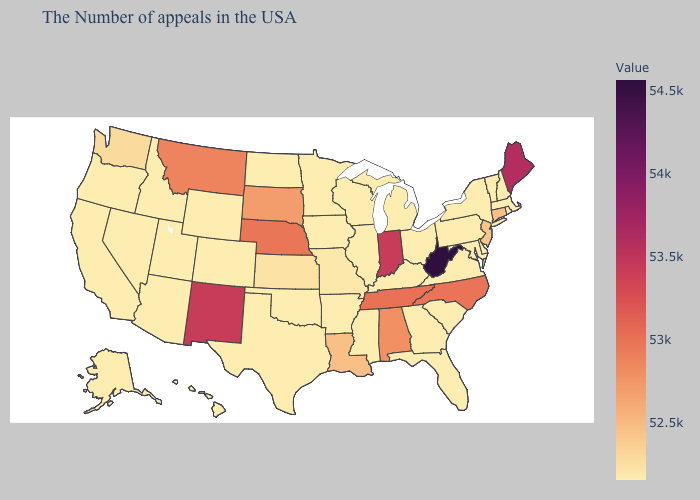Does the map have missing data?
Write a very short answer. No. Does West Virginia have the highest value in the South?
Short answer required. Yes. Does Massachusetts have the highest value in the Northeast?
Answer briefly. No. Does Utah have the lowest value in the USA?
Concise answer only. Yes. Among the states that border Missouri , which have the lowest value?
Answer briefly. Kentucky, Illinois, Arkansas, Iowa, Oklahoma. 